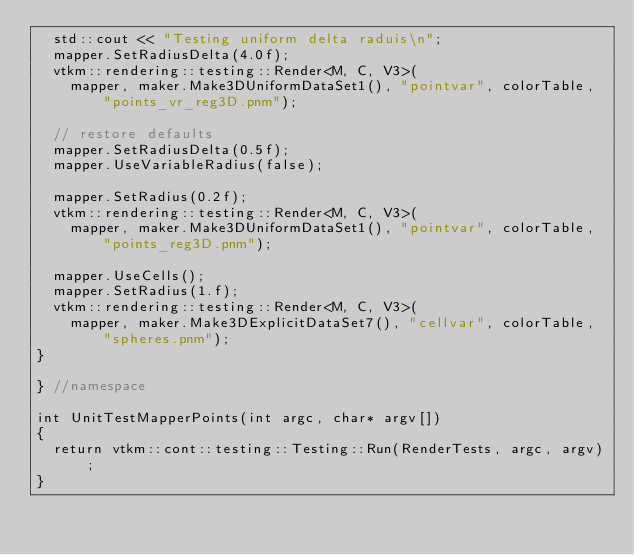Convert code to text. <code><loc_0><loc_0><loc_500><loc_500><_C++_>  std::cout << "Testing uniform delta raduis\n";
  mapper.SetRadiusDelta(4.0f);
  vtkm::rendering::testing::Render<M, C, V3>(
    mapper, maker.Make3DUniformDataSet1(), "pointvar", colorTable, "points_vr_reg3D.pnm");

  // restore defaults
  mapper.SetRadiusDelta(0.5f);
  mapper.UseVariableRadius(false);

  mapper.SetRadius(0.2f);
  vtkm::rendering::testing::Render<M, C, V3>(
    mapper, maker.Make3DUniformDataSet1(), "pointvar", colorTable, "points_reg3D.pnm");

  mapper.UseCells();
  mapper.SetRadius(1.f);
  vtkm::rendering::testing::Render<M, C, V3>(
    mapper, maker.Make3DExplicitDataSet7(), "cellvar", colorTable, "spheres.pnm");
}

} //namespace

int UnitTestMapperPoints(int argc, char* argv[])
{
  return vtkm::cont::testing::Testing::Run(RenderTests, argc, argv);
}
</code> 